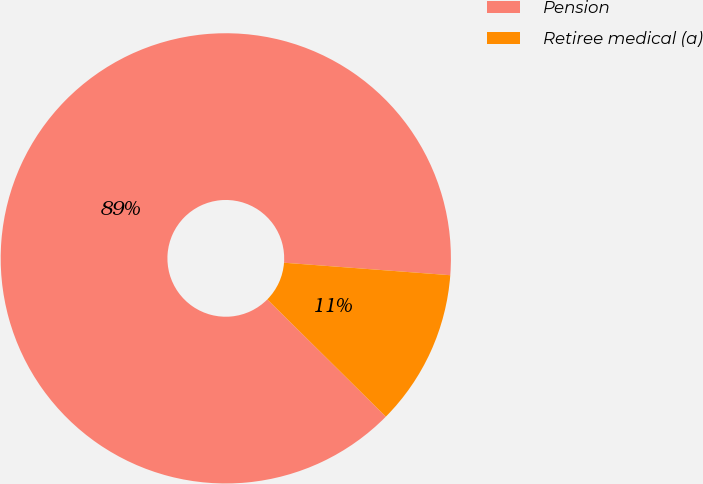<chart> <loc_0><loc_0><loc_500><loc_500><pie_chart><fcel>Pension<fcel>Retiree medical (a)<nl><fcel>88.78%<fcel>11.22%<nl></chart> 